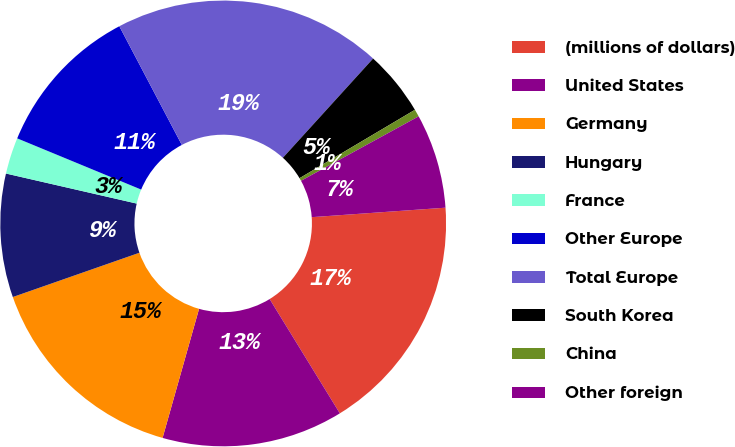<chart> <loc_0><loc_0><loc_500><loc_500><pie_chart><fcel>(millions of dollars)<fcel>United States<fcel>Germany<fcel>Hungary<fcel>France<fcel>Other Europe<fcel>Total Europe<fcel>South Korea<fcel>China<fcel>Other foreign<nl><fcel>17.36%<fcel>13.15%<fcel>15.26%<fcel>8.95%<fcel>2.64%<fcel>11.05%<fcel>19.46%<fcel>4.74%<fcel>0.54%<fcel>6.85%<nl></chart> 